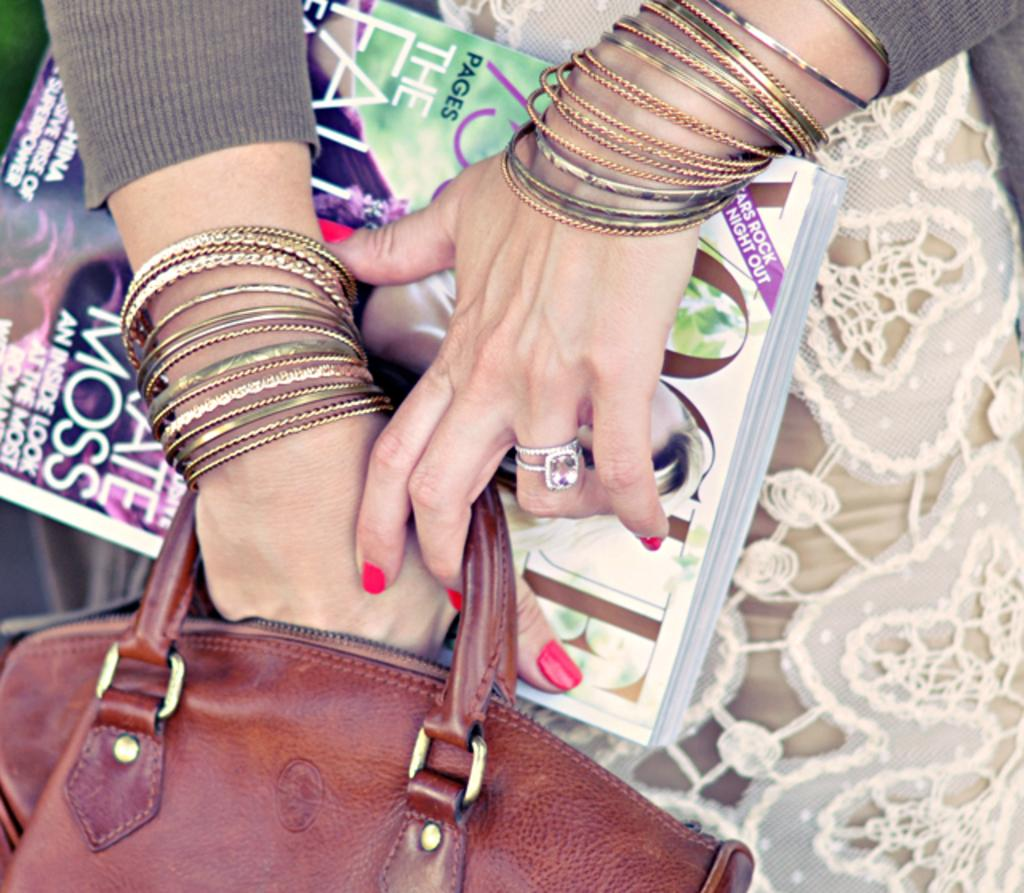Who or what is the main subject in the image? There is a person in the image. What accessories is the person wearing on their hand? The person is wearing bangles and a ring on their hand. What is the person holding in their hand? The person is holding a bag of brown color and a book. What type of soda is the person drinking in the image? There is no soda present in the image; the person is holding a bag and a book. What type of food is the person eating in the image? There is no food present in the image; the person is holding a bag and a book. 